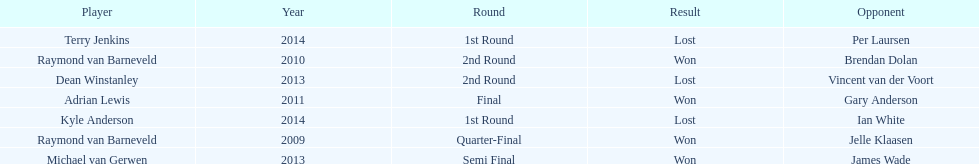Did terry jenkins or per laursen win in 2014? Per Laursen. 